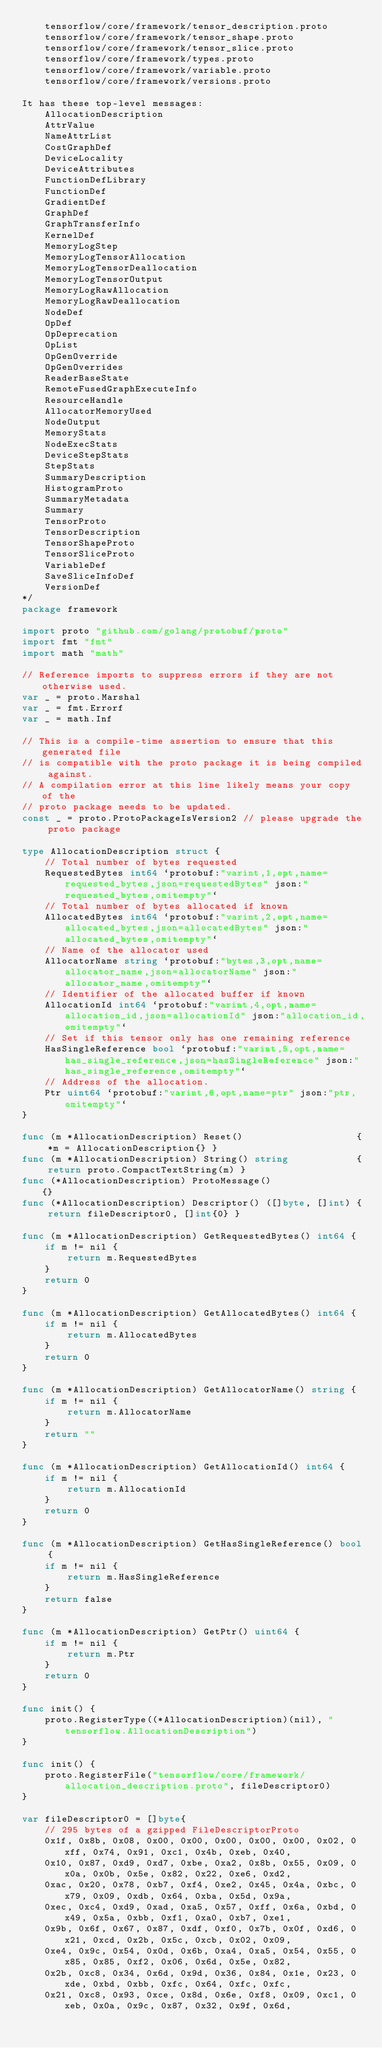<code> <loc_0><loc_0><loc_500><loc_500><_Go_>	tensorflow/core/framework/tensor_description.proto
	tensorflow/core/framework/tensor_shape.proto
	tensorflow/core/framework/tensor_slice.proto
	tensorflow/core/framework/types.proto
	tensorflow/core/framework/variable.proto
	tensorflow/core/framework/versions.proto

It has these top-level messages:
	AllocationDescription
	AttrValue
	NameAttrList
	CostGraphDef
	DeviceLocality
	DeviceAttributes
	FunctionDefLibrary
	FunctionDef
	GradientDef
	GraphDef
	GraphTransferInfo
	KernelDef
	MemoryLogStep
	MemoryLogTensorAllocation
	MemoryLogTensorDeallocation
	MemoryLogTensorOutput
	MemoryLogRawAllocation
	MemoryLogRawDeallocation
	NodeDef
	OpDef
	OpDeprecation
	OpList
	OpGenOverride
	OpGenOverrides
	ReaderBaseState
	RemoteFusedGraphExecuteInfo
	ResourceHandle
	AllocatorMemoryUsed
	NodeOutput
	MemoryStats
	NodeExecStats
	DeviceStepStats
	StepStats
	SummaryDescription
	HistogramProto
	SummaryMetadata
	Summary
	TensorProto
	TensorDescription
	TensorShapeProto
	TensorSliceProto
	VariableDef
	SaveSliceInfoDef
	VersionDef
*/
package framework

import proto "github.com/golang/protobuf/proto"
import fmt "fmt"
import math "math"

// Reference imports to suppress errors if they are not otherwise used.
var _ = proto.Marshal
var _ = fmt.Errorf
var _ = math.Inf

// This is a compile-time assertion to ensure that this generated file
// is compatible with the proto package it is being compiled against.
// A compilation error at this line likely means your copy of the
// proto package needs to be updated.
const _ = proto.ProtoPackageIsVersion2 // please upgrade the proto package

type AllocationDescription struct {
	// Total number of bytes requested
	RequestedBytes int64 `protobuf:"varint,1,opt,name=requested_bytes,json=requestedBytes" json:"requested_bytes,omitempty"`
	// Total number of bytes allocated if known
	AllocatedBytes int64 `protobuf:"varint,2,opt,name=allocated_bytes,json=allocatedBytes" json:"allocated_bytes,omitempty"`
	// Name of the allocator used
	AllocatorName string `protobuf:"bytes,3,opt,name=allocator_name,json=allocatorName" json:"allocator_name,omitempty"`
	// Identifier of the allocated buffer if known
	AllocationId int64 `protobuf:"varint,4,opt,name=allocation_id,json=allocationId" json:"allocation_id,omitempty"`
	// Set if this tensor only has one remaining reference
	HasSingleReference bool `protobuf:"varint,5,opt,name=has_single_reference,json=hasSingleReference" json:"has_single_reference,omitempty"`
	// Address of the allocation.
	Ptr uint64 `protobuf:"varint,6,opt,name=ptr" json:"ptr,omitempty"`
}

func (m *AllocationDescription) Reset()                    { *m = AllocationDescription{} }
func (m *AllocationDescription) String() string            { return proto.CompactTextString(m) }
func (*AllocationDescription) ProtoMessage()               {}
func (*AllocationDescription) Descriptor() ([]byte, []int) { return fileDescriptor0, []int{0} }

func (m *AllocationDescription) GetRequestedBytes() int64 {
	if m != nil {
		return m.RequestedBytes
	}
	return 0
}

func (m *AllocationDescription) GetAllocatedBytes() int64 {
	if m != nil {
		return m.AllocatedBytes
	}
	return 0
}

func (m *AllocationDescription) GetAllocatorName() string {
	if m != nil {
		return m.AllocatorName
	}
	return ""
}

func (m *AllocationDescription) GetAllocationId() int64 {
	if m != nil {
		return m.AllocationId
	}
	return 0
}

func (m *AllocationDescription) GetHasSingleReference() bool {
	if m != nil {
		return m.HasSingleReference
	}
	return false
}

func (m *AllocationDescription) GetPtr() uint64 {
	if m != nil {
		return m.Ptr
	}
	return 0
}

func init() {
	proto.RegisterType((*AllocationDescription)(nil), "tensorflow.AllocationDescription")
}

func init() {
	proto.RegisterFile("tensorflow/core/framework/allocation_description.proto", fileDescriptor0)
}

var fileDescriptor0 = []byte{
	// 295 bytes of a gzipped FileDescriptorProto
	0x1f, 0x8b, 0x08, 0x00, 0x00, 0x00, 0x00, 0x00, 0x02, 0xff, 0x74, 0x91, 0xc1, 0x4b, 0xeb, 0x40,
	0x10, 0x87, 0xd9, 0xd7, 0xbe, 0xa2, 0x8b, 0x55, 0x09, 0x0a, 0x0b, 0x5e, 0x82, 0x22, 0xe6, 0xd2,
	0xac, 0x20, 0x78, 0xb7, 0xf4, 0xe2, 0x45, 0x4a, 0xbc, 0x79, 0x09, 0xdb, 0x64, 0xba, 0x5d, 0x9a,
	0xec, 0xc4, 0xd9, 0xad, 0xa5, 0x57, 0xff, 0x6a, 0xbd, 0x49, 0x5a, 0xbb, 0xf1, 0xa0, 0xb7, 0xe1,
	0x9b, 0x6f, 0x67, 0x87, 0xdf, 0xf0, 0x7b, 0x0f, 0xd6, 0x21, 0xcd, 0x2b, 0x5c, 0xcb, 0x02, 0x09,
	0xe4, 0x9c, 0x54, 0x0d, 0x6b, 0xa4, 0xa5, 0x54, 0x55, 0x85, 0x85, 0xf2, 0x06, 0x6d, 0x5e, 0x82,
	0x2b, 0xc8, 0x34, 0x6d, 0x9d, 0x36, 0x84, 0x1e, 0x23, 0xde, 0xbd, 0xbb, 0xfc, 0x64, 0xfc, 0xfc,
	0x21, 0xc8, 0x93, 0xce, 0x8d, 0x6e, 0xf8, 0x09, 0xc1, 0xeb, 0x0a, 0x9c, 0x87, 0x32, 0x9f, 0x6d,</code> 